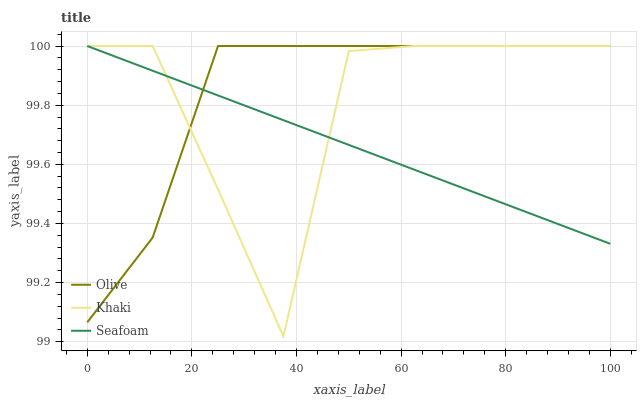Does Seafoam have the minimum area under the curve?
Answer yes or no. Yes. Does Olive have the maximum area under the curve?
Answer yes or no. Yes. Does Khaki have the minimum area under the curve?
Answer yes or no. No. Does Khaki have the maximum area under the curve?
Answer yes or no. No. Is Seafoam the smoothest?
Answer yes or no. Yes. Is Khaki the roughest?
Answer yes or no. Yes. Is Khaki the smoothest?
Answer yes or no. No. Is Seafoam the roughest?
Answer yes or no. No. Does Seafoam have the lowest value?
Answer yes or no. No. 